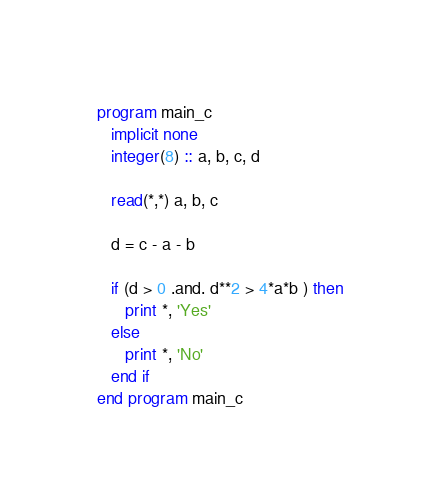<code> <loc_0><loc_0><loc_500><loc_500><_FORTRAN_>program main_c
   implicit none
   integer(8) :: a, b, c, d

   read(*,*) a, b, c

   d = c - a - b

   if (d > 0 .and. d**2 > 4*a*b ) then
      print *, 'Yes'
   else
      print *, 'No'
   end if
end program main_c
</code> 